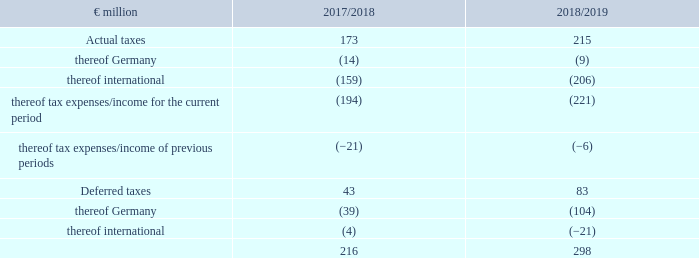Taxes
At €298 million (2017/18: €216 million), recognised income tax expenses are €81 million higher than the previous year’s figures.
During the reporting period, the group tax rate for the continuing segment is 42.0% (2017/18: 37.6%). The group tax rate represents the relationship between recognised income tax expenses and earnings before taxes. The increase in the ratio in the current financial year is mainly attributable to impairments on deferred taxes on loss carry-forwards in Germany. The comparatively low ratio in the previous year includes positive one-off tax effects such as tax rate changes abroad and the reduction for risk provisions.
For more information about income taxes, see the notes to the consolidated financial statements in no. 12 – income taxes page 206 .
1 Adjustment of previous year according to explanation in notes.
What was the amount of recognised income tax expenses in FY2019? €298 million. What does the group tax rate represent? The relationship between recognised income tax expenses and earnings before taxes. What were the components under Deferred taxes in the table? Thereof germany, thereof international. In which year was the total amount of taxes larger? 298>216
Answer: 2018/2019. What was the change in total taxes in  2018/2019 from 2017/2018?
Answer scale should be: million. 298-216
Answer: 82. What was the percentage change in total taxes in  2018/2019 from 2017/2018?
Answer scale should be: percent. (298-216)/216
Answer: 37.96. 